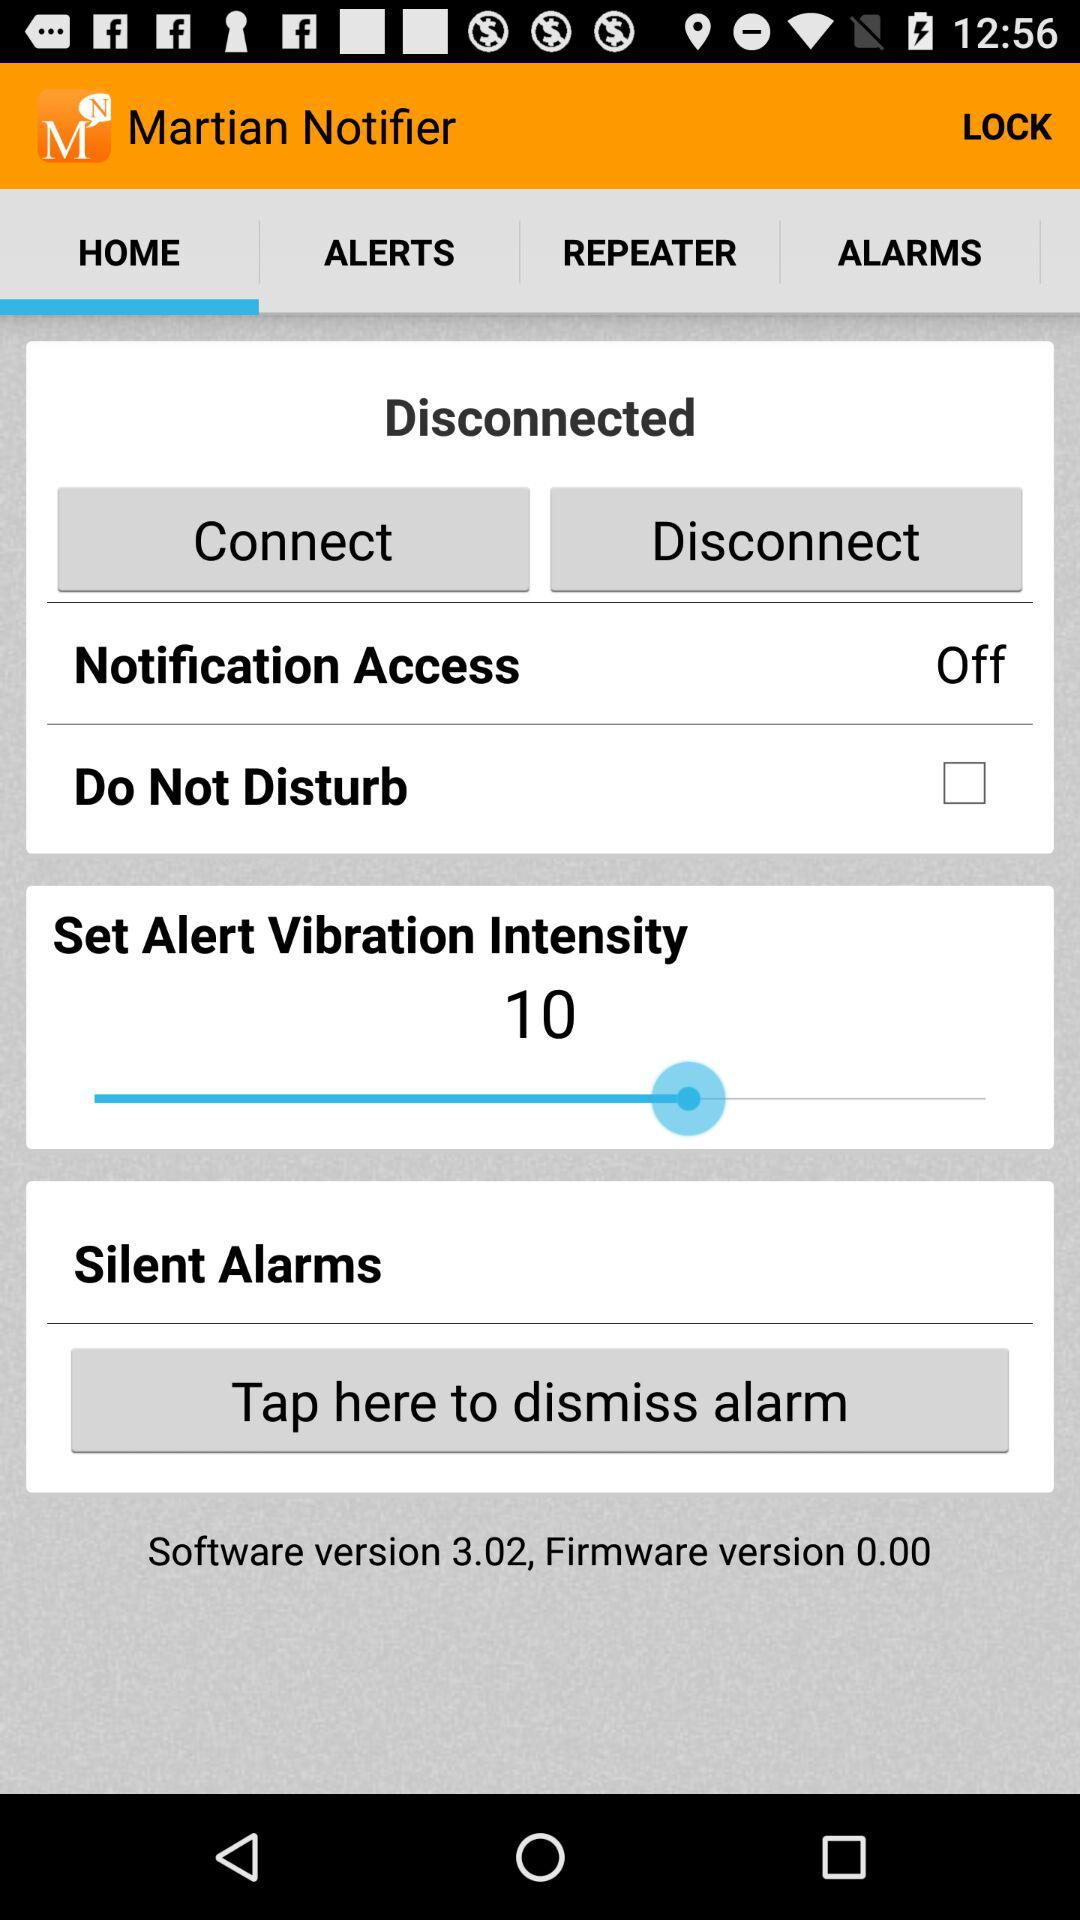What is the software version? The software version is 3.02. 